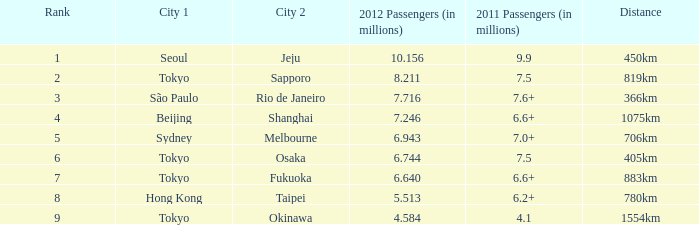In 2011, how many passengers (in millions) traveled on the route which saw 6.6+. 